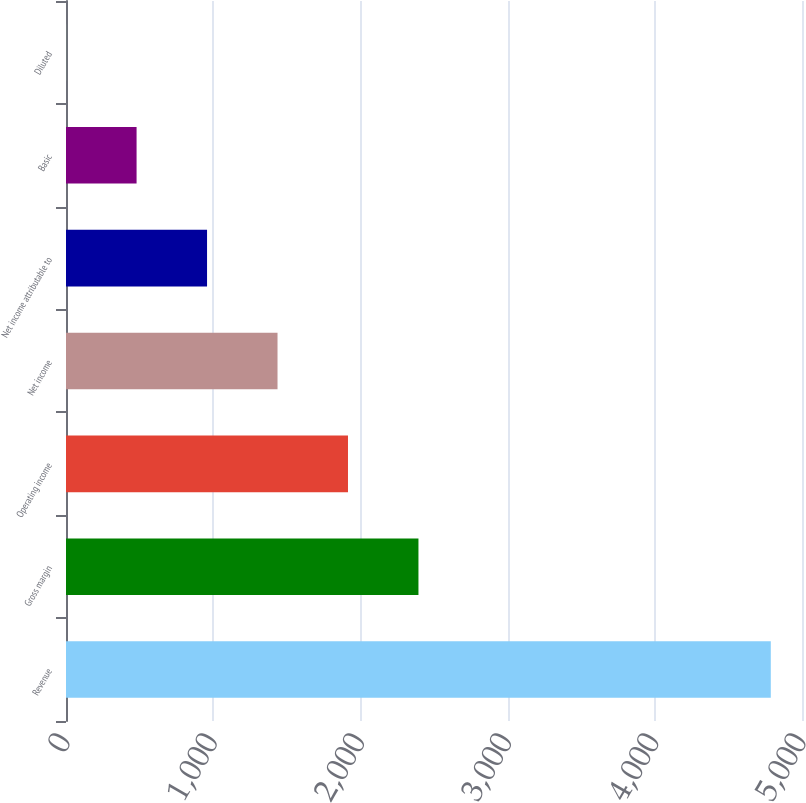Convert chart. <chart><loc_0><loc_0><loc_500><loc_500><bar_chart><fcel>Revenue<fcel>Gross margin<fcel>Operating income<fcel>Net income<fcel>Net income attributable to<fcel>Basic<fcel>Diluted<nl><fcel>4788<fcel>2394.39<fcel>1915.66<fcel>1436.93<fcel>958.2<fcel>479.47<fcel>0.74<nl></chart> 